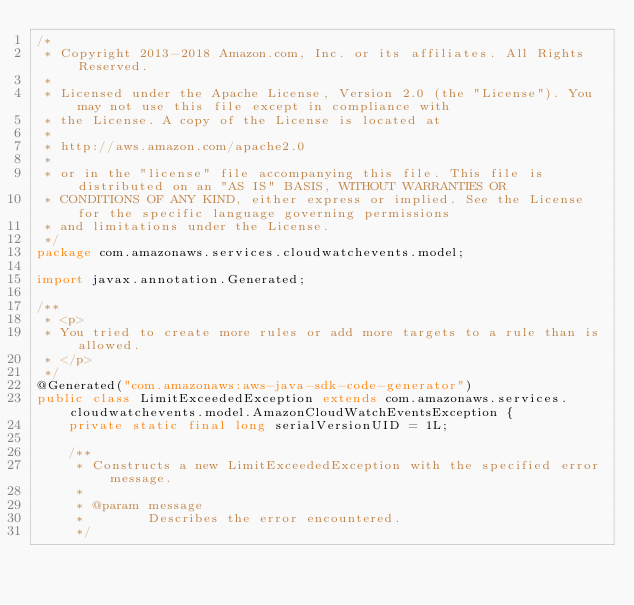<code> <loc_0><loc_0><loc_500><loc_500><_Java_>/*
 * Copyright 2013-2018 Amazon.com, Inc. or its affiliates. All Rights Reserved.
 * 
 * Licensed under the Apache License, Version 2.0 (the "License"). You may not use this file except in compliance with
 * the License. A copy of the License is located at
 * 
 * http://aws.amazon.com/apache2.0
 * 
 * or in the "license" file accompanying this file. This file is distributed on an "AS IS" BASIS, WITHOUT WARRANTIES OR
 * CONDITIONS OF ANY KIND, either express or implied. See the License for the specific language governing permissions
 * and limitations under the License.
 */
package com.amazonaws.services.cloudwatchevents.model;

import javax.annotation.Generated;

/**
 * <p>
 * You tried to create more rules or add more targets to a rule than is allowed.
 * </p>
 */
@Generated("com.amazonaws:aws-java-sdk-code-generator")
public class LimitExceededException extends com.amazonaws.services.cloudwatchevents.model.AmazonCloudWatchEventsException {
    private static final long serialVersionUID = 1L;

    /**
     * Constructs a new LimitExceededException with the specified error message.
     *
     * @param message
     *        Describes the error encountered.
     */</code> 